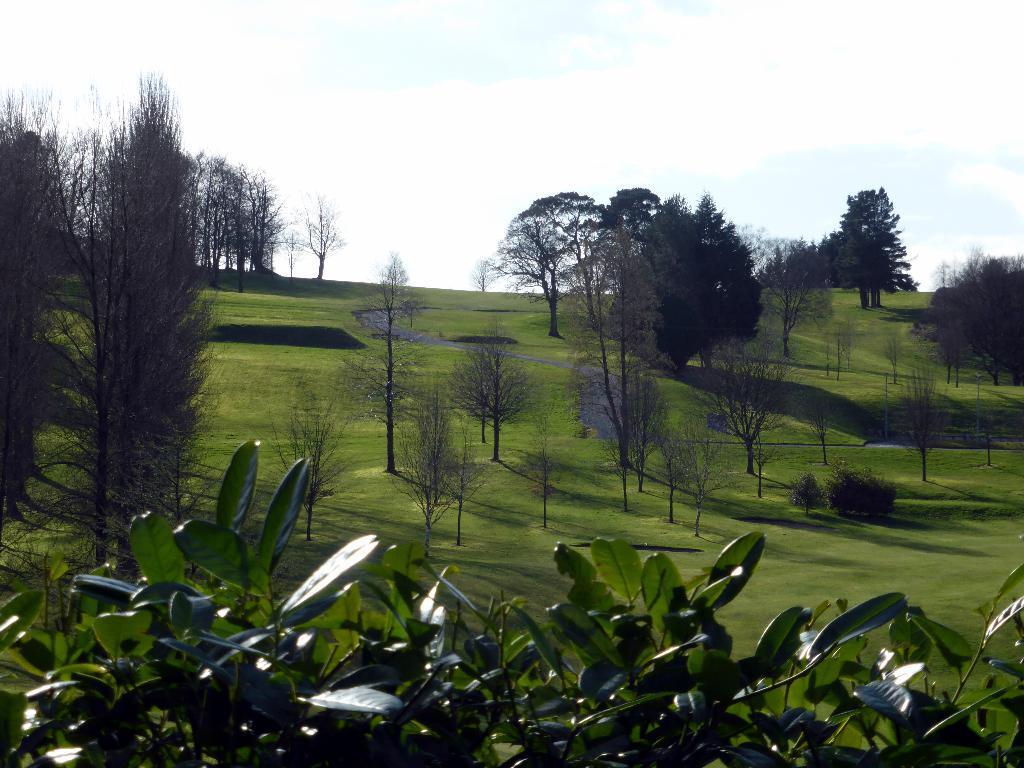Describe this image in one or two sentences. In this image there are trees on the grassland. Bottom of the image there are plants having leaves. Top of the image there is sky. 